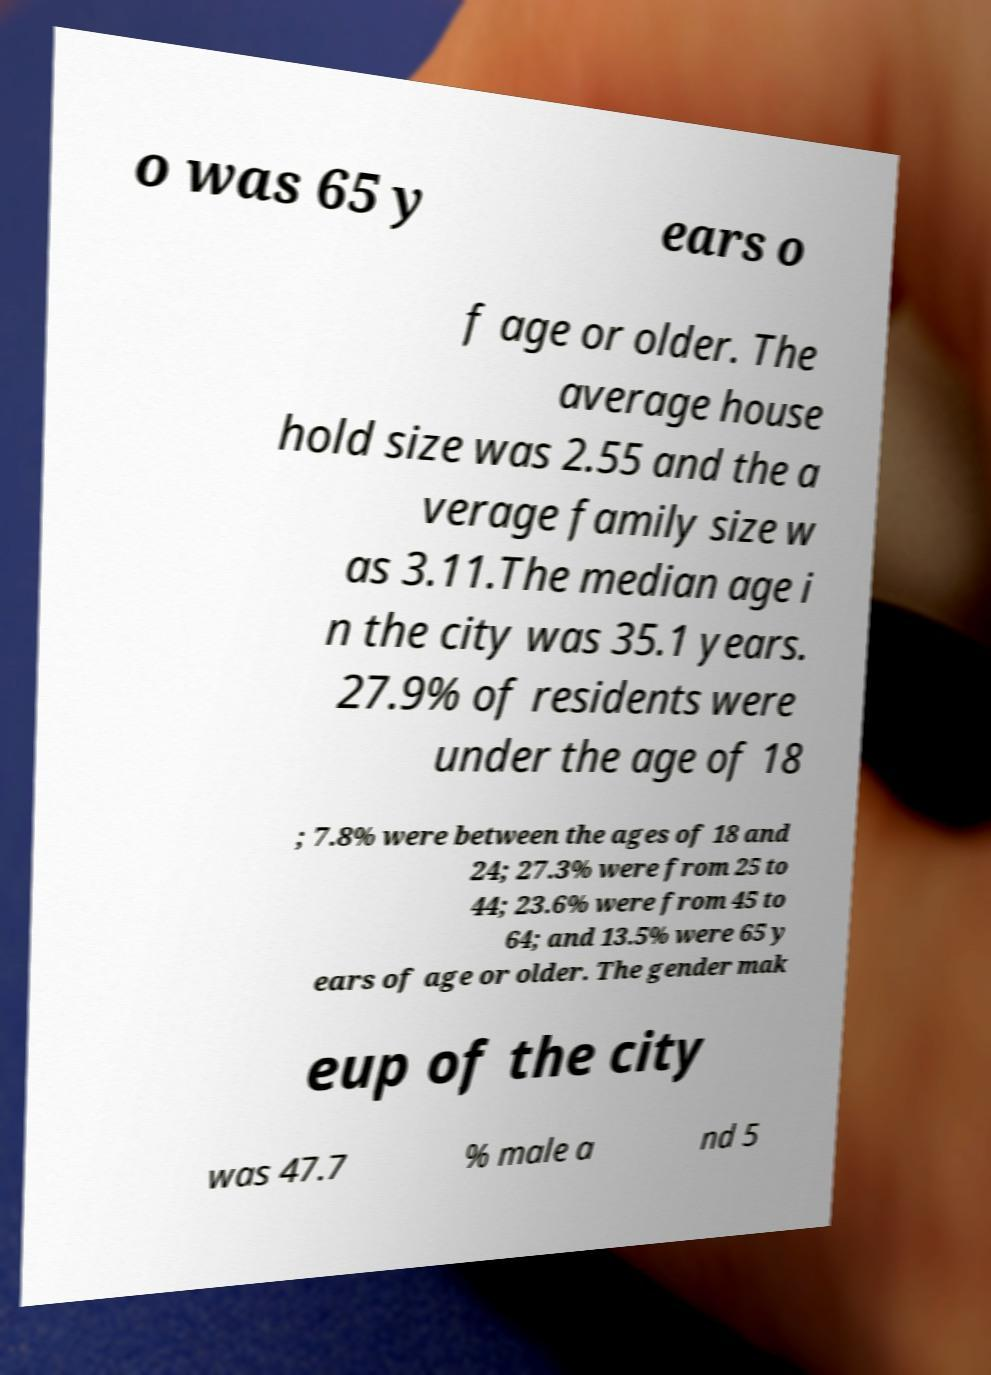Could you extract and type out the text from this image? o was 65 y ears o f age or older. The average house hold size was 2.55 and the a verage family size w as 3.11.The median age i n the city was 35.1 years. 27.9% of residents were under the age of 18 ; 7.8% were between the ages of 18 and 24; 27.3% were from 25 to 44; 23.6% were from 45 to 64; and 13.5% were 65 y ears of age or older. The gender mak eup of the city was 47.7 % male a nd 5 